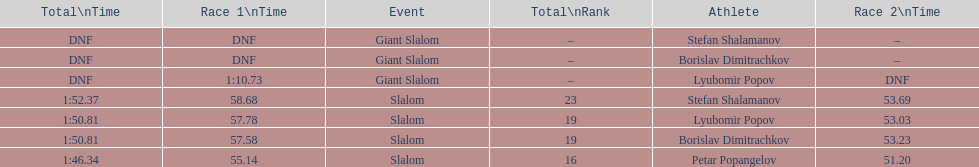How many athletes are there total? 4. 